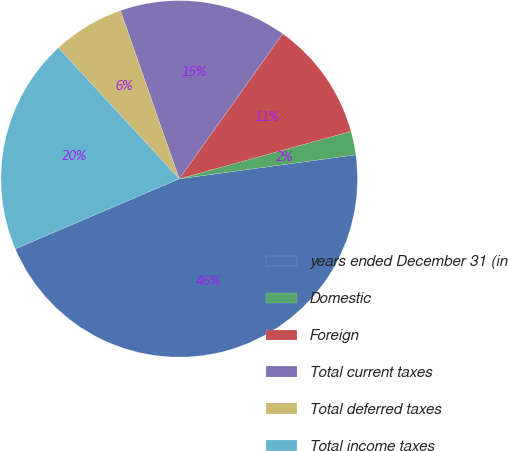<chart> <loc_0><loc_0><loc_500><loc_500><pie_chart><fcel>years ended December 31 (in<fcel>Domestic<fcel>Foreign<fcel>Total current taxes<fcel>Total deferred taxes<fcel>Total income taxes<nl><fcel>45.73%<fcel>2.14%<fcel>10.85%<fcel>15.21%<fcel>6.5%<fcel>19.57%<nl></chart> 